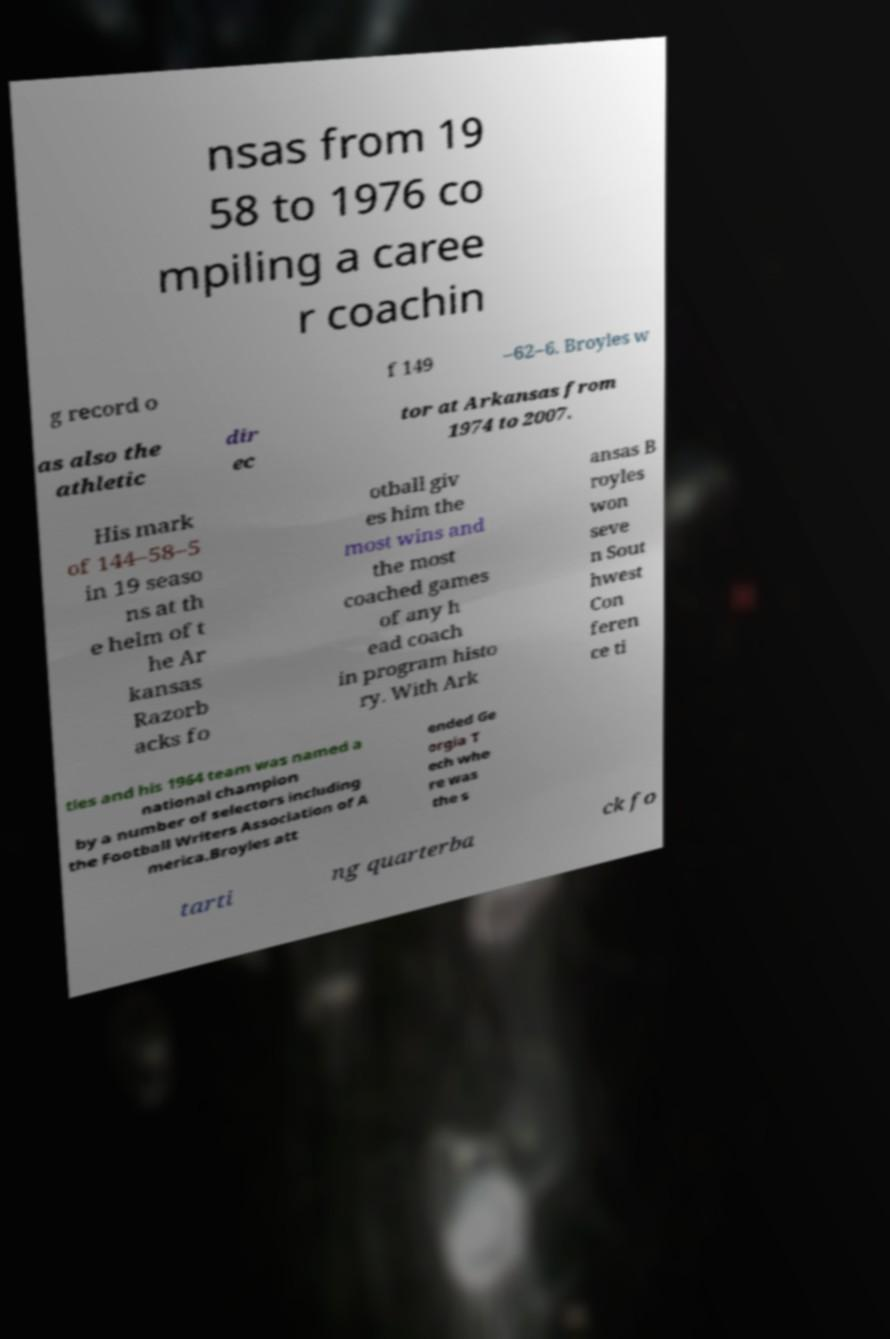Can you read and provide the text displayed in the image?This photo seems to have some interesting text. Can you extract and type it out for me? nsas from 19 58 to 1976 co mpiling a caree r coachin g record o f 149 –62–6. Broyles w as also the athletic dir ec tor at Arkansas from 1974 to 2007. His mark of 144–58–5 in 19 seaso ns at th e helm of t he Ar kansas Razorb acks fo otball giv es him the most wins and the most coached games of any h ead coach in program histo ry. With Ark ansas B royles won seve n Sout hwest Con feren ce ti tles and his 1964 team was named a national champion by a number of selectors including the Football Writers Association of A merica.Broyles att ended Ge orgia T ech whe re was the s tarti ng quarterba ck fo 